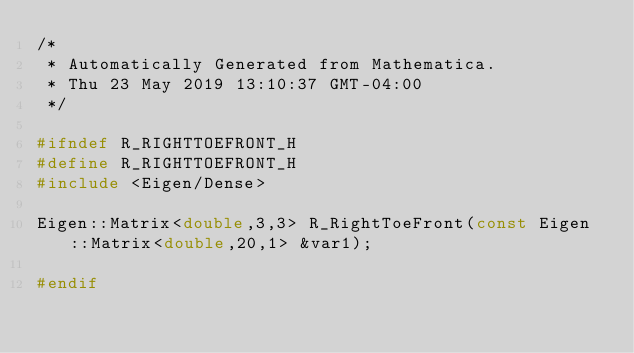Convert code to text. <code><loc_0><loc_0><loc_500><loc_500><_C_>/*
 * Automatically Generated from Mathematica.
 * Thu 23 May 2019 13:10:37 GMT-04:00
 */

#ifndef R_RIGHTTOEFRONT_H
#define R_RIGHTTOEFRONT_H
#include <Eigen/Dense>

Eigen::Matrix<double,3,3> R_RightToeFront(const Eigen::Matrix<double,20,1> &var1);

#endif 


</code> 